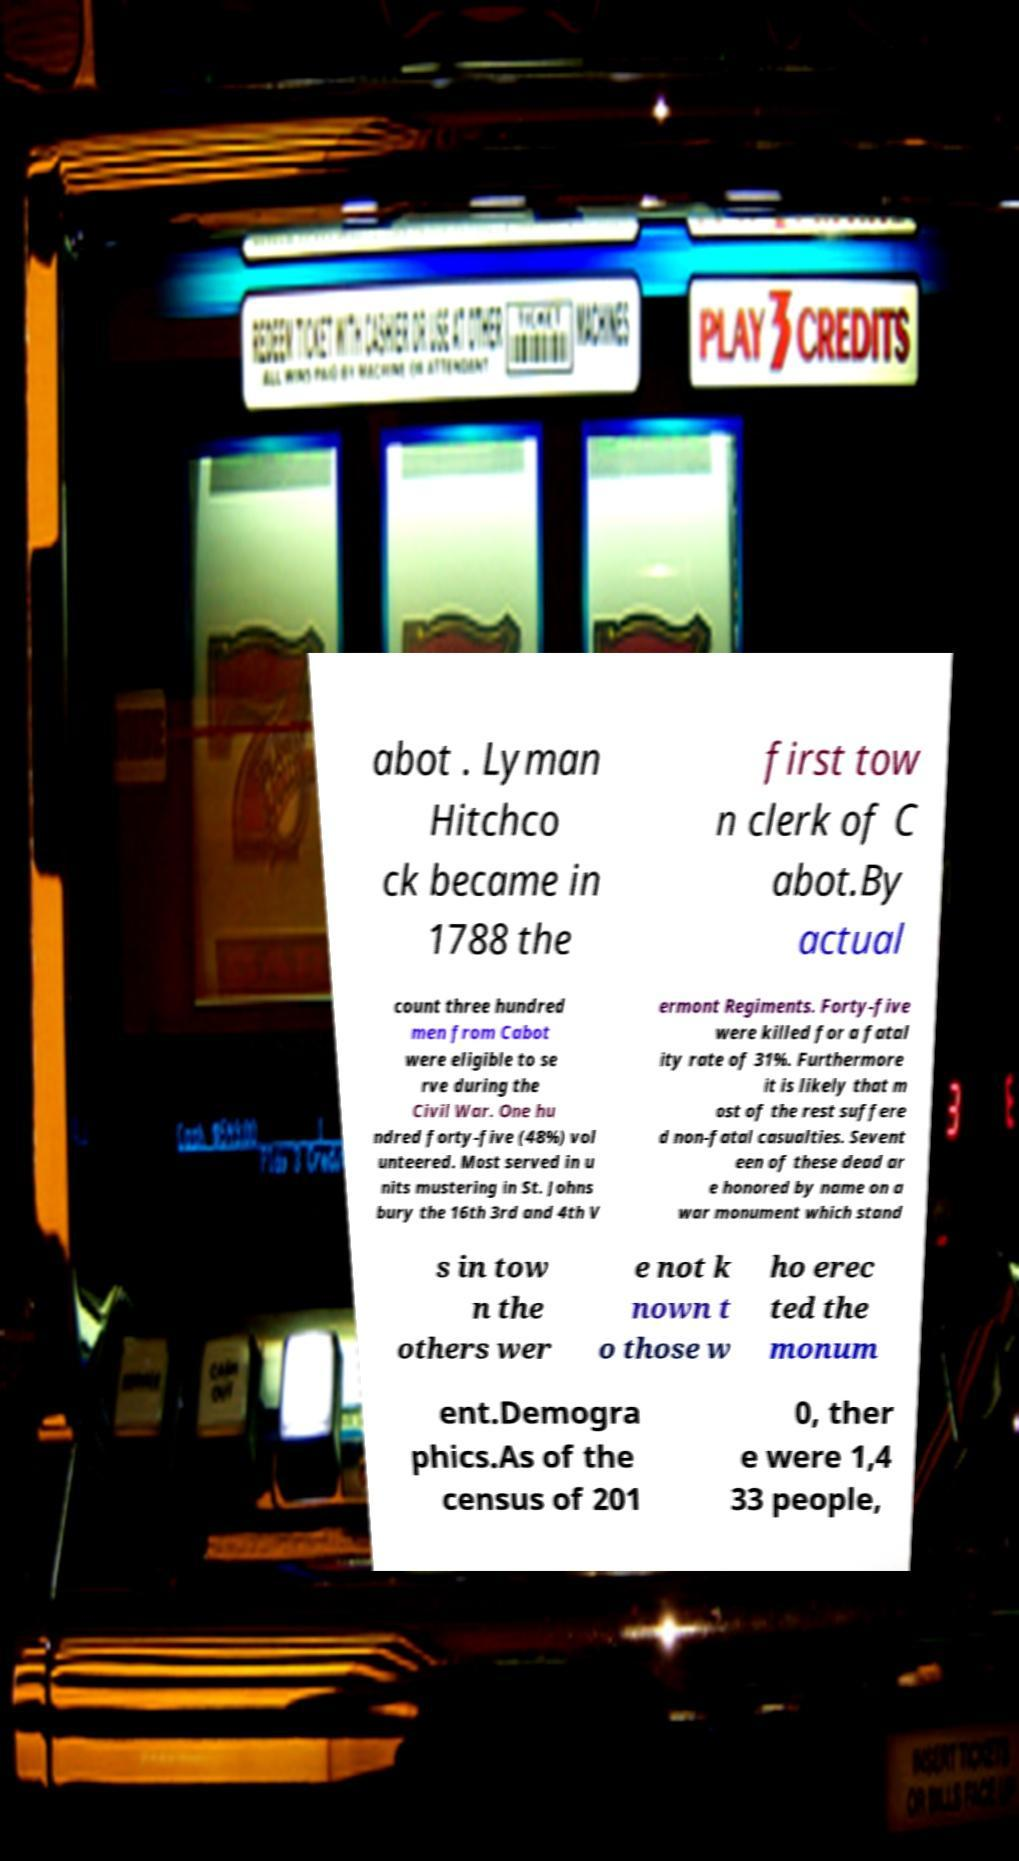Can you read and provide the text displayed in the image?This photo seems to have some interesting text. Can you extract and type it out for me? abot . Lyman Hitchco ck became in 1788 the first tow n clerk of C abot.By actual count three hundred men from Cabot were eligible to se rve during the Civil War. One hu ndred forty-five (48%) vol unteered. Most served in u nits mustering in St. Johns bury the 16th 3rd and 4th V ermont Regiments. Forty-five were killed for a fatal ity rate of 31%. Furthermore it is likely that m ost of the rest suffere d non-fatal casualties. Sevent een of these dead ar e honored by name on a war monument which stand s in tow n the others wer e not k nown t o those w ho erec ted the monum ent.Demogra phics.As of the census of 201 0, ther e were 1,4 33 people, 